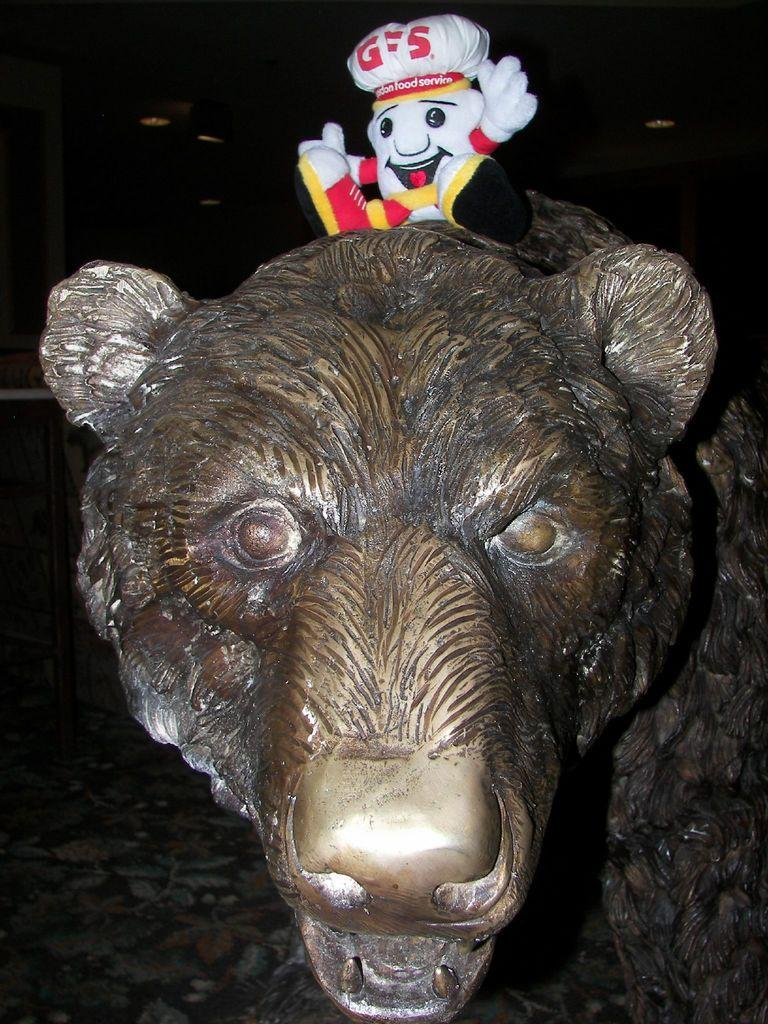What is the main subject in the image? There is a metal tiger statue in the image. Where is the metal tiger statue located in the image? The metal tiger statue is in the front of the image. Is there anything placed on top of the metal tiger statue? Yes, there is a small toy teddy bear on top of the metal tiger statue. What can be observed about the background of the image? The background of the image is dark. What type of game is being played in the image? There is no game being played in the image; it features a metal tiger statue with a toy teddy bear on top. What color is the coat worn by the tiger in the image? There is no tiger wearing a coat in the image; it is a metal tiger statue. 